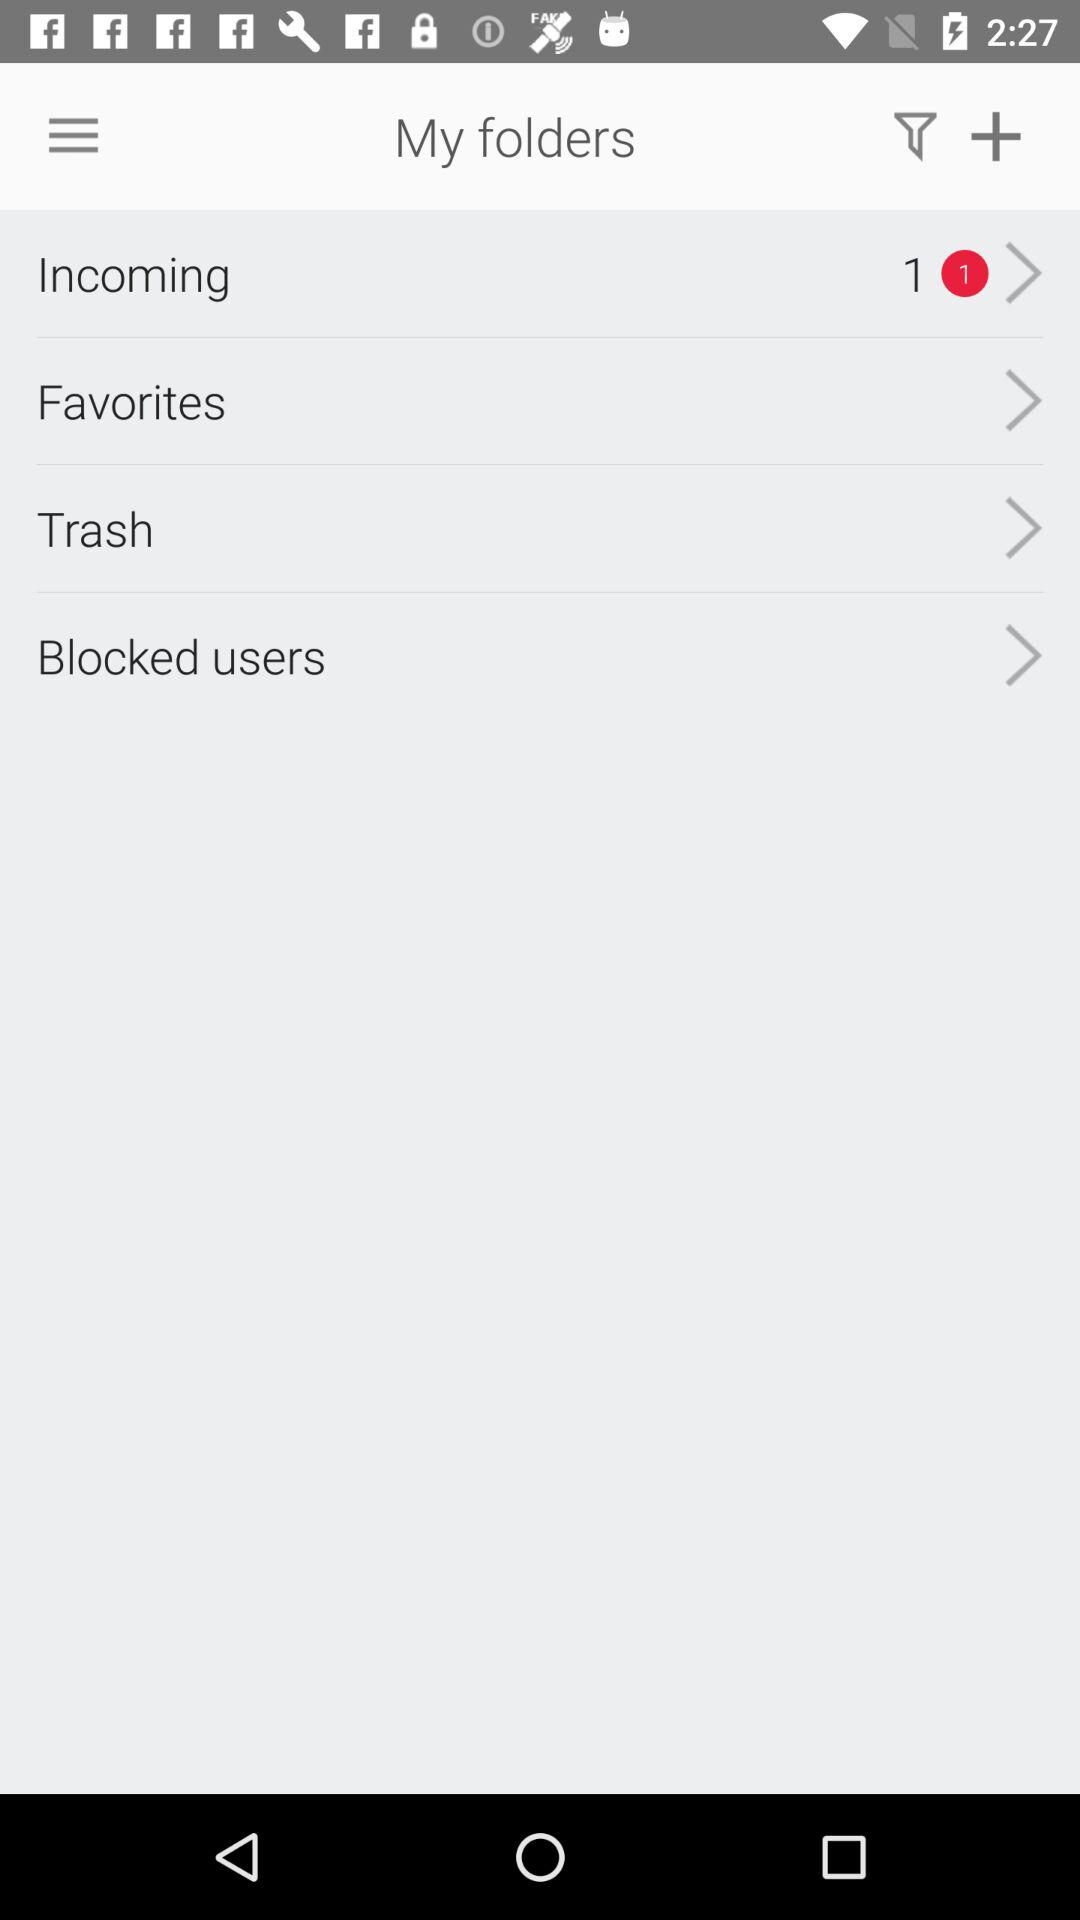What is the number of "Incoming" in "My folders"? The number of "Incoming" is 1. 